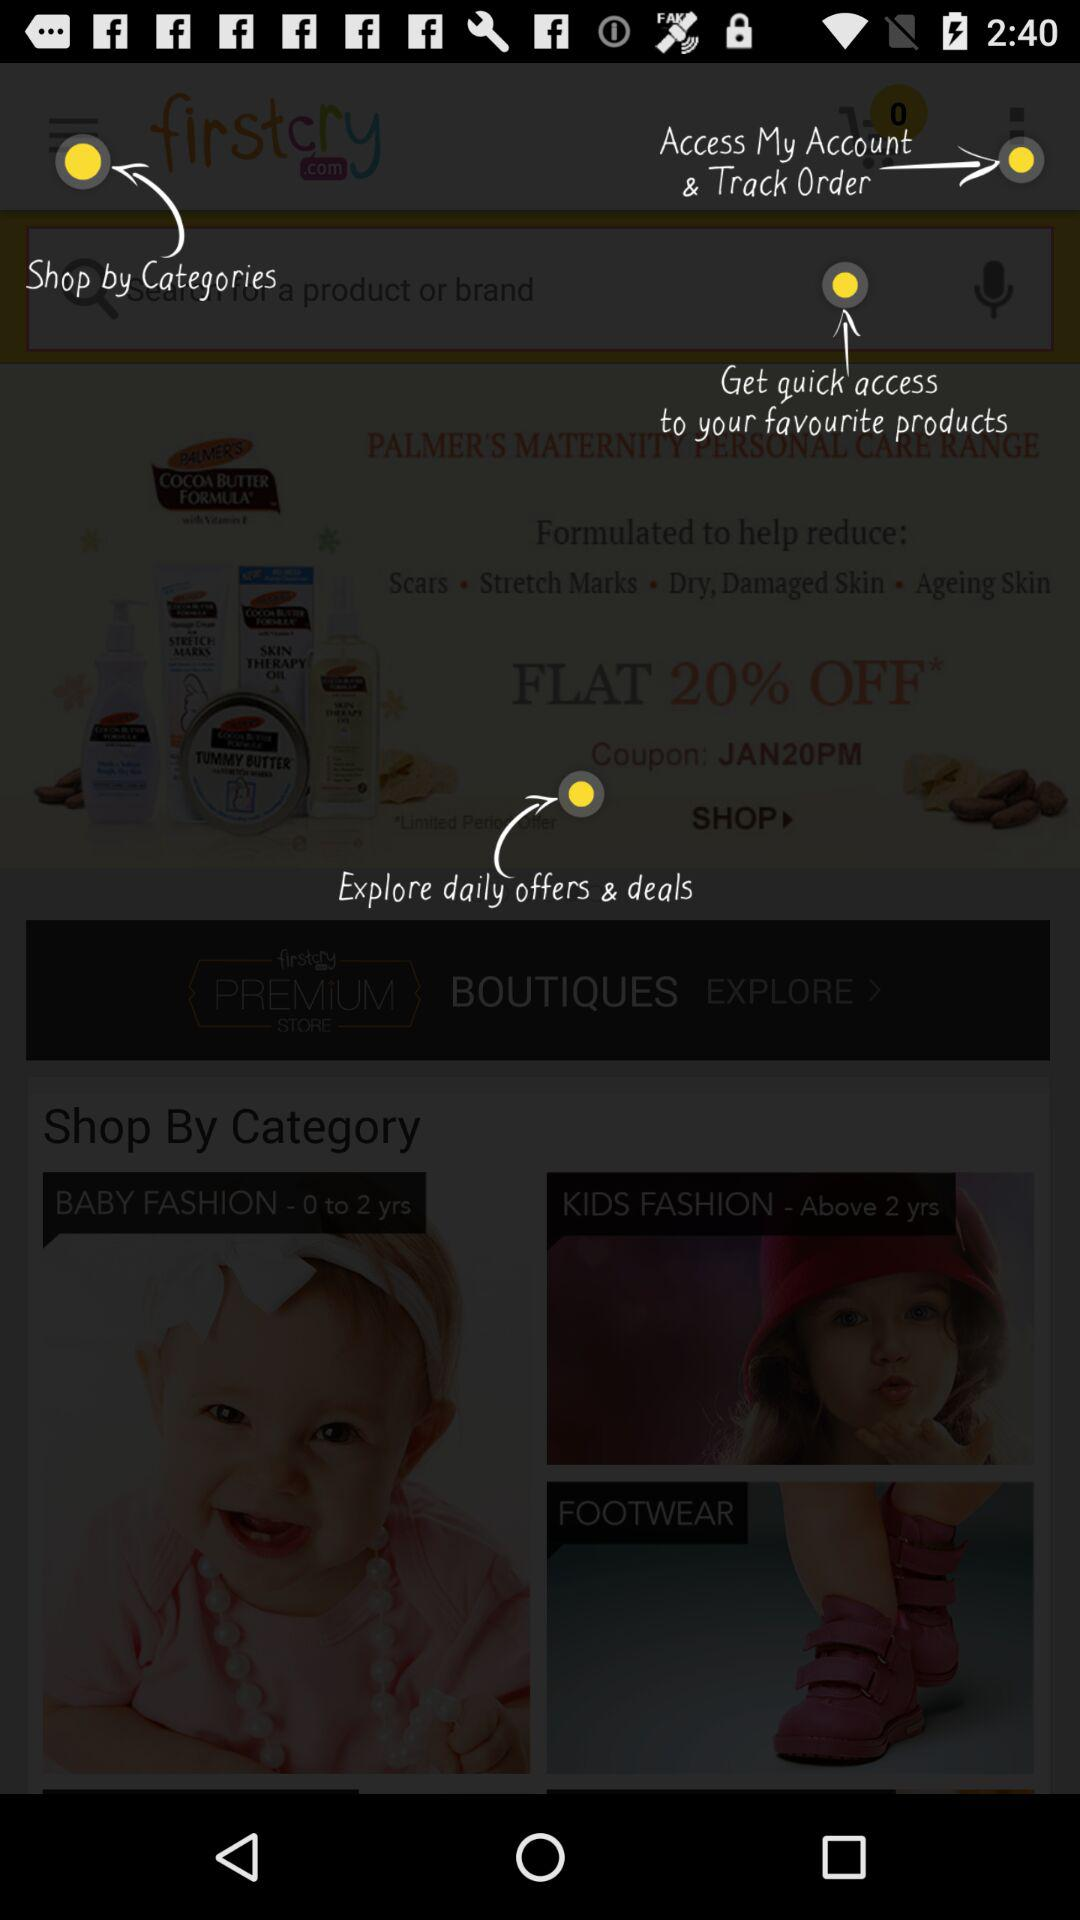What are the different shopping category?
When the provided information is insufficient, respond with <no answer>. <no answer> 